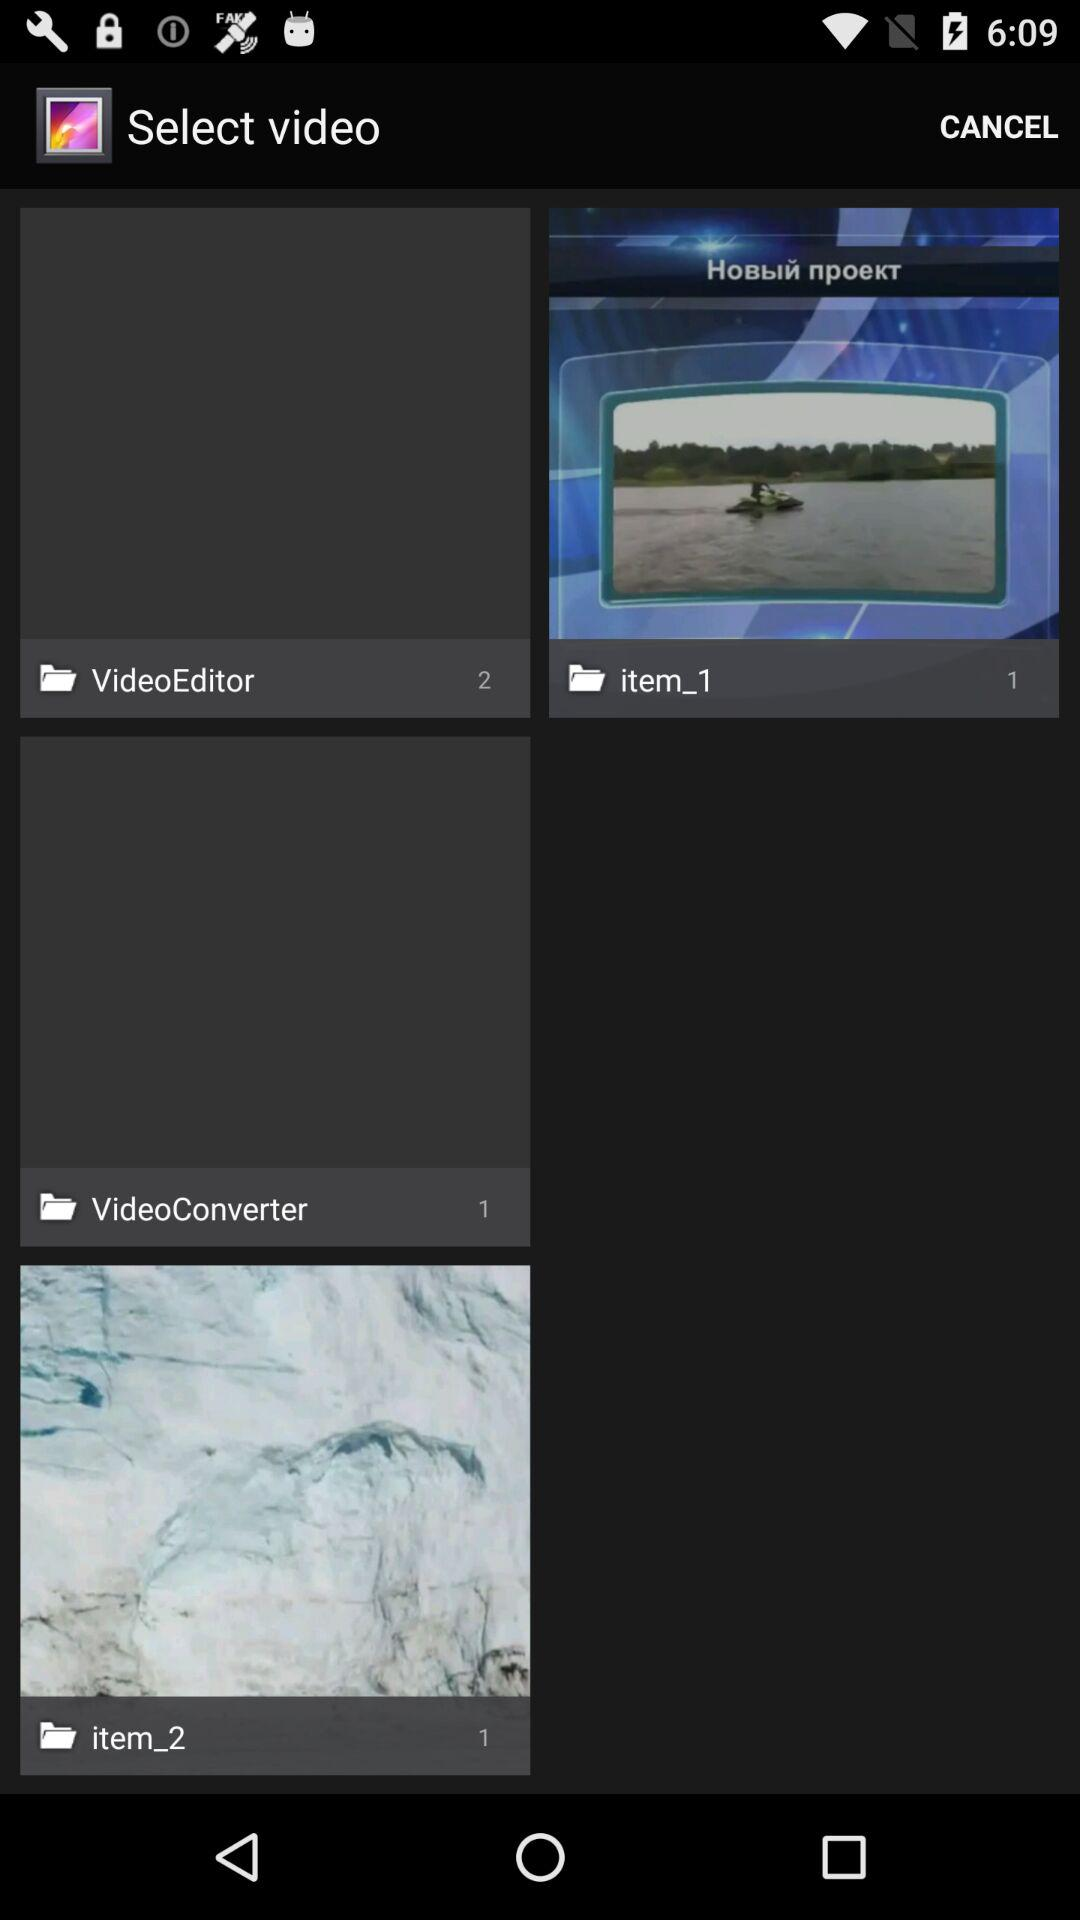Who posted the videos?
When the provided information is insufficient, respond with <no answer>. <no answer> 